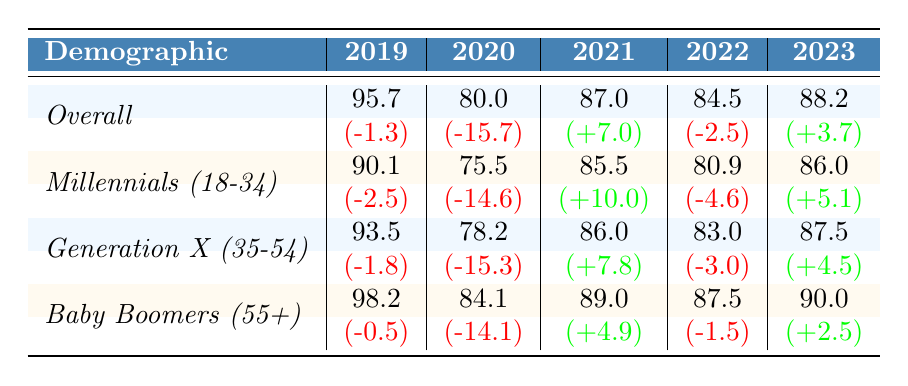What was the consumer sentiment index value for Millennials in 2020? The table shows that the consumer sentiment index value for Millennials (18-34) in 2020 is 75.5.
Answer: 75.5 Which demographic had the highest index value in 2019? In 2019, Baby Boomers (55+) had the highest index value of 98.2 compared to the others listed for that year.
Answer: Baby Boomers (55+) What was the change in the consumer sentiment index for Generation X from 2020 to 2021? The index value for Generation X in 2020 was 78.2 and in 2021 it was 86.0. The change is 86.0 - 78.2 = 7.8, which indicates an increase.
Answer: 7.8 Was there a decline in the overall consumer sentiment index from 2019 to 2020? Yes, the overall index decreased from 95.7 in 2019 to 80.0 in 2020, showing a decline of 15.7.
Answer: Yes How did the consumer sentiment index for Millennials compare between 2021 and 2023? In 2021 the index was 85.5, and in 2023 it increased to 86.0, indicating an upward trend of 0.5.
Answer: Increased by 0.5 What is the average sentiment index for Baby Boomers over the five years reported? The index values for Baby Boomers over the five years are 98.2, 84.1, 89.0, 87.5, and 90.0. The sum is 98.2 + 84.1 + 89.0 + 87.5 + 90.0 = 438.8. Dividing by 5 gives an average of 87.76.
Answer: 87.76 Which year had the lowest consumer sentiment index for Millennials? Referring to the table, the lowest index value for Millennials occurred in 2020 with a value of 75.5.
Answer: 2020 What was the change in sentiment for the overall demographic from 2022 to 2023? The overall index was 84.5 in 2022 and increased to 88.2 in 2023, so the change is 88.2 - 84.5 = 3.7.
Answer: 3.7 Did all demographic groups experience a decline in their consumer sentiment index from 2019 to 2020? Yes, all demographics had a decline in their index, as indicated by the negative changes across all rows for 2020 compared to 2019.
Answer: Yes Which demographic had the smallest change in consumer sentiment from 2020 to 2021? For 2020 and 2021, Baby Boomers showed the least change, increasing by 4.9, while others had larger changes.
Answer: Baby Boomers (55+) 